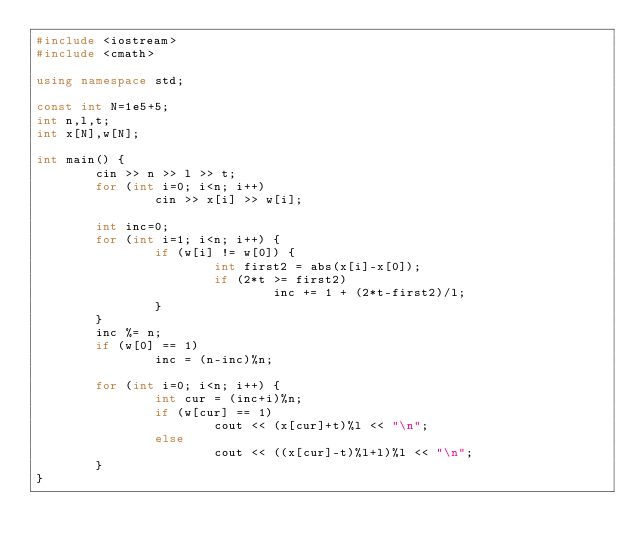Convert code to text. <code><loc_0><loc_0><loc_500><loc_500><_C++_>#include <iostream>
#include <cmath>

using namespace std;

const int N=1e5+5;
int n,l,t;
int x[N],w[N];

int main() {
        cin >> n >> l >> t;
        for (int i=0; i<n; i++)
                cin >> x[i] >> w[i];

        int inc=0;
        for (int i=1; i<n; i++) {
                if (w[i] != w[0]) {
                        int first2 = abs(x[i]-x[0]);
                        if (2*t >= first2)
                                inc += 1 + (2*t-first2)/l;
                }
        }
        inc %= n;
        if (w[0] == 1)
                inc = (n-inc)%n;

        for (int i=0; i<n; i++) {
                int cur = (inc+i)%n;
                if (w[cur] == 1)
                        cout << (x[cur]+t)%l << "\n";
                else
                        cout << ((x[cur]-t)%l+l)%l << "\n";
        }
}</code> 